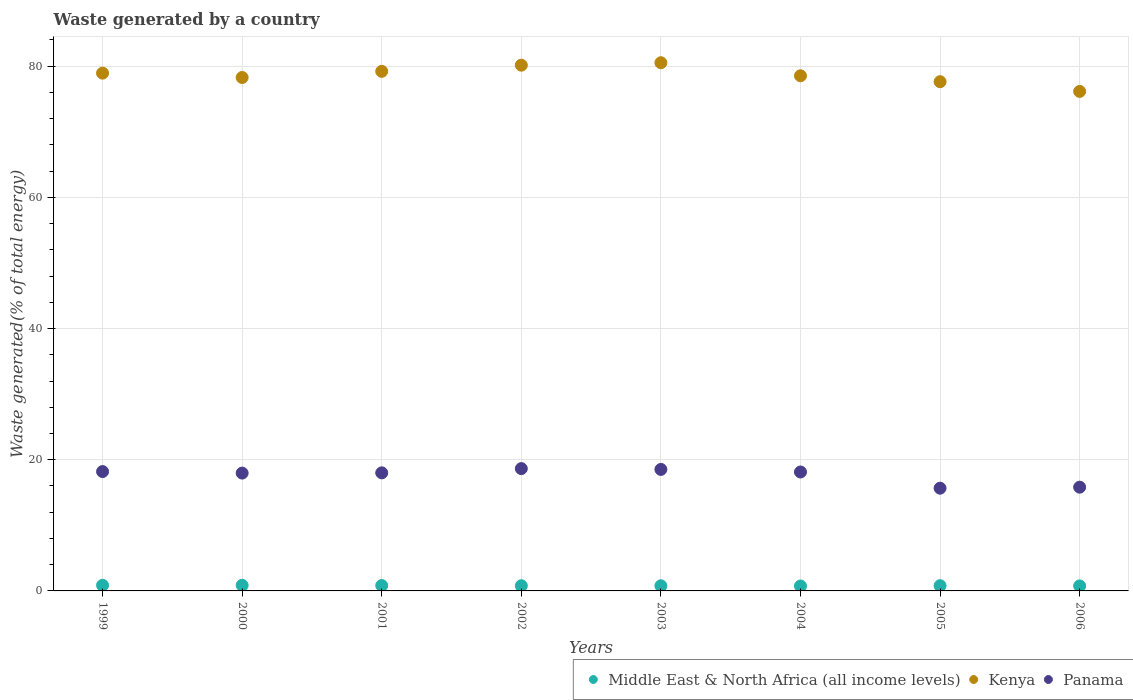How many different coloured dotlines are there?
Give a very brief answer. 3. Is the number of dotlines equal to the number of legend labels?
Offer a terse response. Yes. What is the total waste generated in Panama in 2006?
Keep it short and to the point. 15.82. Across all years, what is the maximum total waste generated in Middle East & North Africa (all income levels)?
Your response must be concise. 0.86. Across all years, what is the minimum total waste generated in Panama?
Your answer should be compact. 15.66. In which year was the total waste generated in Kenya maximum?
Give a very brief answer. 2003. What is the total total waste generated in Kenya in the graph?
Provide a succinct answer. 629.43. What is the difference between the total waste generated in Middle East & North Africa (all income levels) in 2003 and that in 2004?
Your answer should be very brief. 0.03. What is the difference between the total waste generated in Middle East & North Africa (all income levels) in 1999 and the total waste generated in Panama in 2005?
Give a very brief answer. -14.81. What is the average total waste generated in Middle East & North Africa (all income levels) per year?
Your answer should be compact. 0.8. In the year 2002, what is the difference between the total waste generated in Middle East & North Africa (all income levels) and total waste generated in Kenya?
Offer a very short reply. -79.36. What is the ratio of the total waste generated in Middle East & North Africa (all income levels) in 2002 to that in 2004?
Offer a very short reply. 1.05. What is the difference between the highest and the second highest total waste generated in Middle East & North Africa (all income levels)?
Ensure brevity in your answer.  0. What is the difference between the highest and the lowest total waste generated in Kenya?
Your answer should be compact. 4.37. In how many years, is the total waste generated in Panama greater than the average total waste generated in Panama taken over all years?
Ensure brevity in your answer.  6. Is the sum of the total waste generated in Middle East & North Africa (all income levels) in 2003 and 2004 greater than the maximum total waste generated in Panama across all years?
Make the answer very short. No. Is it the case that in every year, the sum of the total waste generated in Middle East & North Africa (all income levels) and total waste generated in Panama  is greater than the total waste generated in Kenya?
Your answer should be very brief. No. Does the total waste generated in Panama monotonically increase over the years?
Make the answer very short. No. Is the total waste generated in Panama strictly greater than the total waste generated in Kenya over the years?
Make the answer very short. No. Is the total waste generated in Middle East & North Africa (all income levels) strictly less than the total waste generated in Panama over the years?
Offer a very short reply. Yes. How many dotlines are there?
Keep it short and to the point. 3. How many years are there in the graph?
Offer a terse response. 8. What is the difference between two consecutive major ticks on the Y-axis?
Your answer should be very brief. 20. Are the values on the major ticks of Y-axis written in scientific E-notation?
Provide a short and direct response. No. Does the graph contain any zero values?
Offer a terse response. No. Where does the legend appear in the graph?
Your response must be concise. Bottom right. How are the legend labels stacked?
Ensure brevity in your answer.  Horizontal. What is the title of the graph?
Your response must be concise. Waste generated by a country. Does "West Bank and Gaza" appear as one of the legend labels in the graph?
Offer a very short reply. No. What is the label or title of the Y-axis?
Make the answer very short. Waste generated(% of total energy). What is the Waste generated(% of total energy) of Middle East & North Africa (all income levels) in 1999?
Your answer should be compact. 0.86. What is the Waste generated(% of total energy) in Kenya in 1999?
Provide a short and direct response. 78.94. What is the Waste generated(% of total energy) in Panama in 1999?
Your response must be concise. 18.2. What is the Waste generated(% of total energy) of Middle East & North Africa (all income levels) in 2000?
Give a very brief answer. 0.86. What is the Waste generated(% of total energy) of Kenya in 2000?
Make the answer very short. 78.28. What is the Waste generated(% of total energy) in Panama in 2000?
Offer a terse response. 17.96. What is the Waste generated(% of total energy) of Middle East & North Africa (all income levels) in 2001?
Give a very brief answer. 0.82. What is the Waste generated(% of total energy) of Kenya in 2001?
Offer a very short reply. 79.21. What is the Waste generated(% of total energy) of Panama in 2001?
Provide a short and direct response. 18. What is the Waste generated(% of total energy) in Middle East & North Africa (all income levels) in 2002?
Offer a terse response. 0.79. What is the Waste generated(% of total energy) in Kenya in 2002?
Ensure brevity in your answer.  80.15. What is the Waste generated(% of total energy) in Panama in 2002?
Provide a succinct answer. 18.65. What is the Waste generated(% of total energy) in Middle East & North Africa (all income levels) in 2003?
Offer a terse response. 0.78. What is the Waste generated(% of total energy) of Kenya in 2003?
Offer a very short reply. 80.52. What is the Waste generated(% of total energy) in Panama in 2003?
Ensure brevity in your answer.  18.52. What is the Waste generated(% of total energy) of Middle East & North Africa (all income levels) in 2004?
Your answer should be compact. 0.75. What is the Waste generated(% of total energy) of Kenya in 2004?
Your response must be concise. 78.54. What is the Waste generated(% of total energy) in Panama in 2004?
Give a very brief answer. 18.13. What is the Waste generated(% of total energy) in Middle East & North Africa (all income levels) in 2005?
Give a very brief answer. 0.8. What is the Waste generated(% of total energy) of Kenya in 2005?
Your answer should be compact. 77.63. What is the Waste generated(% of total energy) of Panama in 2005?
Keep it short and to the point. 15.66. What is the Waste generated(% of total energy) in Middle East & North Africa (all income levels) in 2006?
Offer a terse response. 0.77. What is the Waste generated(% of total energy) in Kenya in 2006?
Provide a succinct answer. 76.15. What is the Waste generated(% of total energy) of Panama in 2006?
Provide a short and direct response. 15.82. Across all years, what is the maximum Waste generated(% of total energy) of Middle East & North Africa (all income levels)?
Offer a very short reply. 0.86. Across all years, what is the maximum Waste generated(% of total energy) of Kenya?
Provide a short and direct response. 80.52. Across all years, what is the maximum Waste generated(% of total energy) of Panama?
Give a very brief answer. 18.65. Across all years, what is the minimum Waste generated(% of total energy) of Middle East & North Africa (all income levels)?
Keep it short and to the point. 0.75. Across all years, what is the minimum Waste generated(% of total energy) in Kenya?
Your answer should be very brief. 76.15. Across all years, what is the minimum Waste generated(% of total energy) in Panama?
Keep it short and to the point. 15.66. What is the total Waste generated(% of total energy) in Middle East & North Africa (all income levels) in the graph?
Offer a terse response. 6.42. What is the total Waste generated(% of total energy) of Kenya in the graph?
Provide a succinct answer. 629.42. What is the total Waste generated(% of total energy) of Panama in the graph?
Make the answer very short. 140.94. What is the difference between the Waste generated(% of total energy) in Middle East & North Africa (all income levels) in 1999 and that in 2000?
Keep it short and to the point. 0. What is the difference between the Waste generated(% of total energy) in Kenya in 1999 and that in 2000?
Make the answer very short. 0.66. What is the difference between the Waste generated(% of total energy) of Panama in 1999 and that in 2000?
Ensure brevity in your answer.  0.23. What is the difference between the Waste generated(% of total energy) in Middle East & North Africa (all income levels) in 1999 and that in 2001?
Provide a succinct answer. 0.04. What is the difference between the Waste generated(% of total energy) of Kenya in 1999 and that in 2001?
Offer a terse response. -0.27. What is the difference between the Waste generated(% of total energy) in Panama in 1999 and that in 2001?
Your response must be concise. 0.2. What is the difference between the Waste generated(% of total energy) of Middle East & North Africa (all income levels) in 1999 and that in 2002?
Your answer should be compact. 0.07. What is the difference between the Waste generated(% of total energy) in Kenya in 1999 and that in 2002?
Your response must be concise. -1.21. What is the difference between the Waste generated(% of total energy) of Panama in 1999 and that in 2002?
Provide a short and direct response. -0.45. What is the difference between the Waste generated(% of total energy) of Middle East & North Africa (all income levels) in 1999 and that in 2003?
Make the answer very short. 0.08. What is the difference between the Waste generated(% of total energy) of Kenya in 1999 and that in 2003?
Make the answer very short. -1.59. What is the difference between the Waste generated(% of total energy) of Panama in 1999 and that in 2003?
Provide a short and direct response. -0.32. What is the difference between the Waste generated(% of total energy) in Middle East & North Africa (all income levels) in 1999 and that in 2004?
Your response must be concise. 0.11. What is the difference between the Waste generated(% of total energy) in Kenya in 1999 and that in 2004?
Provide a succinct answer. 0.4. What is the difference between the Waste generated(% of total energy) in Panama in 1999 and that in 2004?
Offer a very short reply. 0.07. What is the difference between the Waste generated(% of total energy) of Middle East & North Africa (all income levels) in 1999 and that in 2005?
Ensure brevity in your answer.  0.06. What is the difference between the Waste generated(% of total energy) in Kenya in 1999 and that in 2005?
Offer a terse response. 1.3. What is the difference between the Waste generated(% of total energy) in Panama in 1999 and that in 2005?
Your answer should be very brief. 2.53. What is the difference between the Waste generated(% of total energy) of Middle East & North Africa (all income levels) in 1999 and that in 2006?
Your response must be concise. 0.09. What is the difference between the Waste generated(% of total energy) of Kenya in 1999 and that in 2006?
Your response must be concise. 2.79. What is the difference between the Waste generated(% of total energy) of Panama in 1999 and that in 2006?
Offer a terse response. 2.38. What is the difference between the Waste generated(% of total energy) in Middle East & North Africa (all income levels) in 2000 and that in 2001?
Your answer should be compact. 0.04. What is the difference between the Waste generated(% of total energy) of Kenya in 2000 and that in 2001?
Make the answer very short. -0.93. What is the difference between the Waste generated(% of total energy) in Panama in 2000 and that in 2001?
Your answer should be very brief. -0.04. What is the difference between the Waste generated(% of total energy) of Middle East & North Africa (all income levels) in 2000 and that in 2002?
Provide a succinct answer. 0.06. What is the difference between the Waste generated(% of total energy) of Kenya in 2000 and that in 2002?
Offer a very short reply. -1.88. What is the difference between the Waste generated(% of total energy) of Panama in 2000 and that in 2002?
Your answer should be very brief. -0.68. What is the difference between the Waste generated(% of total energy) of Middle East & North Africa (all income levels) in 2000 and that in 2003?
Keep it short and to the point. 0.07. What is the difference between the Waste generated(% of total energy) in Kenya in 2000 and that in 2003?
Give a very brief answer. -2.25. What is the difference between the Waste generated(% of total energy) of Panama in 2000 and that in 2003?
Provide a short and direct response. -0.56. What is the difference between the Waste generated(% of total energy) of Middle East & North Africa (all income levels) in 2000 and that in 2004?
Make the answer very short. 0.1. What is the difference between the Waste generated(% of total energy) in Kenya in 2000 and that in 2004?
Ensure brevity in your answer.  -0.26. What is the difference between the Waste generated(% of total energy) in Panama in 2000 and that in 2004?
Offer a terse response. -0.17. What is the difference between the Waste generated(% of total energy) of Middle East & North Africa (all income levels) in 2000 and that in 2005?
Keep it short and to the point. 0.06. What is the difference between the Waste generated(% of total energy) of Kenya in 2000 and that in 2005?
Offer a very short reply. 0.64. What is the difference between the Waste generated(% of total energy) of Panama in 2000 and that in 2005?
Offer a very short reply. 2.3. What is the difference between the Waste generated(% of total energy) in Middle East & North Africa (all income levels) in 2000 and that in 2006?
Offer a very short reply. 0.09. What is the difference between the Waste generated(% of total energy) of Kenya in 2000 and that in 2006?
Keep it short and to the point. 2.12. What is the difference between the Waste generated(% of total energy) of Panama in 2000 and that in 2006?
Offer a very short reply. 2.15. What is the difference between the Waste generated(% of total energy) of Middle East & North Africa (all income levels) in 2001 and that in 2002?
Keep it short and to the point. 0.03. What is the difference between the Waste generated(% of total energy) of Kenya in 2001 and that in 2002?
Make the answer very short. -0.94. What is the difference between the Waste generated(% of total energy) of Panama in 2001 and that in 2002?
Offer a terse response. -0.65. What is the difference between the Waste generated(% of total energy) of Middle East & North Africa (all income levels) in 2001 and that in 2003?
Offer a very short reply. 0.04. What is the difference between the Waste generated(% of total energy) in Kenya in 2001 and that in 2003?
Offer a terse response. -1.31. What is the difference between the Waste generated(% of total energy) in Panama in 2001 and that in 2003?
Your answer should be compact. -0.52. What is the difference between the Waste generated(% of total energy) in Middle East & North Africa (all income levels) in 2001 and that in 2004?
Give a very brief answer. 0.07. What is the difference between the Waste generated(% of total energy) in Kenya in 2001 and that in 2004?
Ensure brevity in your answer.  0.67. What is the difference between the Waste generated(% of total energy) in Panama in 2001 and that in 2004?
Your answer should be very brief. -0.13. What is the difference between the Waste generated(% of total energy) of Middle East & North Africa (all income levels) in 2001 and that in 2005?
Your response must be concise. 0.02. What is the difference between the Waste generated(% of total energy) of Kenya in 2001 and that in 2005?
Ensure brevity in your answer.  1.58. What is the difference between the Waste generated(% of total energy) in Panama in 2001 and that in 2005?
Your answer should be compact. 2.34. What is the difference between the Waste generated(% of total energy) of Middle East & North Africa (all income levels) in 2001 and that in 2006?
Give a very brief answer. 0.05. What is the difference between the Waste generated(% of total energy) of Kenya in 2001 and that in 2006?
Give a very brief answer. 3.06. What is the difference between the Waste generated(% of total energy) of Panama in 2001 and that in 2006?
Your response must be concise. 2.19. What is the difference between the Waste generated(% of total energy) of Middle East & North Africa (all income levels) in 2002 and that in 2003?
Keep it short and to the point. 0.01. What is the difference between the Waste generated(% of total energy) in Kenya in 2002 and that in 2003?
Your response must be concise. -0.37. What is the difference between the Waste generated(% of total energy) of Panama in 2002 and that in 2003?
Your answer should be compact. 0.13. What is the difference between the Waste generated(% of total energy) of Middle East & North Africa (all income levels) in 2002 and that in 2004?
Offer a terse response. 0.04. What is the difference between the Waste generated(% of total energy) of Kenya in 2002 and that in 2004?
Offer a very short reply. 1.62. What is the difference between the Waste generated(% of total energy) of Panama in 2002 and that in 2004?
Provide a short and direct response. 0.52. What is the difference between the Waste generated(% of total energy) of Middle East & North Africa (all income levels) in 2002 and that in 2005?
Make the answer very short. -0.01. What is the difference between the Waste generated(% of total energy) in Kenya in 2002 and that in 2005?
Your answer should be very brief. 2.52. What is the difference between the Waste generated(% of total energy) in Panama in 2002 and that in 2005?
Provide a succinct answer. 2.98. What is the difference between the Waste generated(% of total energy) of Middle East & North Africa (all income levels) in 2002 and that in 2006?
Your answer should be compact. 0.02. What is the difference between the Waste generated(% of total energy) in Kenya in 2002 and that in 2006?
Offer a terse response. 4. What is the difference between the Waste generated(% of total energy) in Panama in 2002 and that in 2006?
Give a very brief answer. 2.83. What is the difference between the Waste generated(% of total energy) of Middle East & North Africa (all income levels) in 2003 and that in 2004?
Offer a terse response. 0.03. What is the difference between the Waste generated(% of total energy) of Kenya in 2003 and that in 2004?
Your answer should be compact. 1.99. What is the difference between the Waste generated(% of total energy) in Panama in 2003 and that in 2004?
Ensure brevity in your answer.  0.39. What is the difference between the Waste generated(% of total energy) in Middle East & North Africa (all income levels) in 2003 and that in 2005?
Offer a terse response. -0.01. What is the difference between the Waste generated(% of total energy) of Kenya in 2003 and that in 2005?
Keep it short and to the point. 2.89. What is the difference between the Waste generated(% of total energy) in Panama in 2003 and that in 2005?
Ensure brevity in your answer.  2.86. What is the difference between the Waste generated(% of total energy) in Middle East & North Africa (all income levels) in 2003 and that in 2006?
Provide a short and direct response. 0.02. What is the difference between the Waste generated(% of total energy) of Kenya in 2003 and that in 2006?
Keep it short and to the point. 4.37. What is the difference between the Waste generated(% of total energy) in Panama in 2003 and that in 2006?
Ensure brevity in your answer.  2.71. What is the difference between the Waste generated(% of total energy) in Middle East & North Africa (all income levels) in 2004 and that in 2005?
Keep it short and to the point. -0.05. What is the difference between the Waste generated(% of total energy) of Kenya in 2004 and that in 2005?
Provide a succinct answer. 0.9. What is the difference between the Waste generated(% of total energy) in Panama in 2004 and that in 2005?
Give a very brief answer. 2.47. What is the difference between the Waste generated(% of total energy) in Middle East & North Africa (all income levels) in 2004 and that in 2006?
Your answer should be compact. -0.02. What is the difference between the Waste generated(% of total energy) in Kenya in 2004 and that in 2006?
Make the answer very short. 2.38. What is the difference between the Waste generated(% of total energy) of Panama in 2004 and that in 2006?
Offer a very short reply. 2.32. What is the difference between the Waste generated(% of total energy) in Middle East & North Africa (all income levels) in 2005 and that in 2006?
Offer a very short reply. 0.03. What is the difference between the Waste generated(% of total energy) of Kenya in 2005 and that in 2006?
Offer a terse response. 1.48. What is the difference between the Waste generated(% of total energy) in Panama in 2005 and that in 2006?
Keep it short and to the point. -0.15. What is the difference between the Waste generated(% of total energy) of Middle East & North Africa (all income levels) in 1999 and the Waste generated(% of total energy) of Kenya in 2000?
Your answer should be compact. -77.42. What is the difference between the Waste generated(% of total energy) of Middle East & North Africa (all income levels) in 1999 and the Waste generated(% of total energy) of Panama in 2000?
Keep it short and to the point. -17.11. What is the difference between the Waste generated(% of total energy) in Kenya in 1999 and the Waste generated(% of total energy) in Panama in 2000?
Give a very brief answer. 60.97. What is the difference between the Waste generated(% of total energy) in Middle East & North Africa (all income levels) in 1999 and the Waste generated(% of total energy) in Kenya in 2001?
Make the answer very short. -78.35. What is the difference between the Waste generated(% of total energy) in Middle East & North Africa (all income levels) in 1999 and the Waste generated(% of total energy) in Panama in 2001?
Ensure brevity in your answer.  -17.14. What is the difference between the Waste generated(% of total energy) in Kenya in 1999 and the Waste generated(% of total energy) in Panama in 2001?
Keep it short and to the point. 60.94. What is the difference between the Waste generated(% of total energy) in Middle East & North Africa (all income levels) in 1999 and the Waste generated(% of total energy) in Kenya in 2002?
Provide a short and direct response. -79.29. What is the difference between the Waste generated(% of total energy) of Middle East & North Africa (all income levels) in 1999 and the Waste generated(% of total energy) of Panama in 2002?
Your answer should be compact. -17.79. What is the difference between the Waste generated(% of total energy) of Kenya in 1999 and the Waste generated(% of total energy) of Panama in 2002?
Offer a terse response. 60.29. What is the difference between the Waste generated(% of total energy) of Middle East & North Africa (all income levels) in 1999 and the Waste generated(% of total energy) of Kenya in 2003?
Ensure brevity in your answer.  -79.67. What is the difference between the Waste generated(% of total energy) of Middle East & North Africa (all income levels) in 1999 and the Waste generated(% of total energy) of Panama in 2003?
Your response must be concise. -17.66. What is the difference between the Waste generated(% of total energy) of Kenya in 1999 and the Waste generated(% of total energy) of Panama in 2003?
Your answer should be compact. 60.42. What is the difference between the Waste generated(% of total energy) in Middle East & North Africa (all income levels) in 1999 and the Waste generated(% of total energy) in Kenya in 2004?
Keep it short and to the point. -77.68. What is the difference between the Waste generated(% of total energy) of Middle East & North Africa (all income levels) in 1999 and the Waste generated(% of total energy) of Panama in 2004?
Provide a short and direct response. -17.27. What is the difference between the Waste generated(% of total energy) of Kenya in 1999 and the Waste generated(% of total energy) of Panama in 2004?
Your answer should be compact. 60.81. What is the difference between the Waste generated(% of total energy) in Middle East & North Africa (all income levels) in 1999 and the Waste generated(% of total energy) in Kenya in 2005?
Your answer should be very brief. -76.78. What is the difference between the Waste generated(% of total energy) in Middle East & North Africa (all income levels) in 1999 and the Waste generated(% of total energy) in Panama in 2005?
Keep it short and to the point. -14.81. What is the difference between the Waste generated(% of total energy) in Kenya in 1999 and the Waste generated(% of total energy) in Panama in 2005?
Keep it short and to the point. 63.28. What is the difference between the Waste generated(% of total energy) of Middle East & North Africa (all income levels) in 1999 and the Waste generated(% of total energy) of Kenya in 2006?
Keep it short and to the point. -75.29. What is the difference between the Waste generated(% of total energy) in Middle East & North Africa (all income levels) in 1999 and the Waste generated(% of total energy) in Panama in 2006?
Give a very brief answer. -14.96. What is the difference between the Waste generated(% of total energy) in Kenya in 1999 and the Waste generated(% of total energy) in Panama in 2006?
Your answer should be compact. 63.12. What is the difference between the Waste generated(% of total energy) of Middle East & North Africa (all income levels) in 2000 and the Waste generated(% of total energy) of Kenya in 2001?
Provide a short and direct response. -78.35. What is the difference between the Waste generated(% of total energy) in Middle East & North Africa (all income levels) in 2000 and the Waste generated(% of total energy) in Panama in 2001?
Make the answer very short. -17.15. What is the difference between the Waste generated(% of total energy) of Kenya in 2000 and the Waste generated(% of total energy) of Panama in 2001?
Ensure brevity in your answer.  60.27. What is the difference between the Waste generated(% of total energy) in Middle East & North Africa (all income levels) in 2000 and the Waste generated(% of total energy) in Kenya in 2002?
Provide a succinct answer. -79.3. What is the difference between the Waste generated(% of total energy) of Middle East & North Africa (all income levels) in 2000 and the Waste generated(% of total energy) of Panama in 2002?
Ensure brevity in your answer.  -17.79. What is the difference between the Waste generated(% of total energy) in Kenya in 2000 and the Waste generated(% of total energy) in Panama in 2002?
Give a very brief answer. 59.63. What is the difference between the Waste generated(% of total energy) of Middle East & North Africa (all income levels) in 2000 and the Waste generated(% of total energy) of Kenya in 2003?
Offer a very short reply. -79.67. What is the difference between the Waste generated(% of total energy) in Middle East & North Africa (all income levels) in 2000 and the Waste generated(% of total energy) in Panama in 2003?
Provide a short and direct response. -17.67. What is the difference between the Waste generated(% of total energy) in Kenya in 2000 and the Waste generated(% of total energy) in Panama in 2003?
Offer a very short reply. 59.75. What is the difference between the Waste generated(% of total energy) in Middle East & North Africa (all income levels) in 2000 and the Waste generated(% of total energy) in Kenya in 2004?
Your response must be concise. -77.68. What is the difference between the Waste generated(% of total energy) of Middle East & North Africa (all income levels) in 2000 and the Waste generated(% of total energy) of Panama in 2004?
Your response must be concise. -17.28. What is the difference between the Waste generated(% of total energy) in Kenya in 2000 and the Waste generated(% of total energy) in Panama in 2004?
Offer a very short reply. 60.14. What is the difference between the Waste generated(% of total energy) in Middle East & North Africa (all income levels) in 2000 and the Waste generated(% of total energy) in Kenya in 2005?
Provide a succinct answer. -76.78. What is the difference between the Waste generated(% of total energy) of Middle East & North Africa (all income levels) in 2000 and the Waste generated(% of total energy) of Panama in 2005?
Ensure brevity in your answer.  -14.81. What is the difference between the Waste generated(% of total energy) in Kenya in 2000 and the Waste generated(% of total energy) in Panama in 2005?
Provide a short and direct response. 62.61. What is the difference between the Waste generated(% of total energy) in Middle East & North Africa (all income levels) in 2000 and the Waste generated(% of total energy) in Kenya in 2006?
Your answer should be very brief. -75.3. What is the difference between the Waste generated(% of total energy) in Middle East & North Africa (all income levels) in 2000 and the Waste generated(% of total energy) in Panama in 2006?
Your answer should be compact. -14.96. What is the difference between the Waste generated(% of total energy) in Kenya in 2000 and the Waste generated(% of total energy) in Panama in 2006?
Offer a terse response. 62.46. What is the difference between the Waste generated(% of total energy) in Middle East & North Africa (all income levels) in 2001 and the Waste generated(% of total energy) in Kenya in 2002?
Give a very brief answer. -79.33. What is the difference between the Waste generated(% of total energy) of Middle East & North Africa (all income levels) in 2001 and the Waste generated(% of total energy) of Panama in 2002?
Provide a short and direct response. -17.83. What is the difference between the Waste generated(% of total energy) in Kenya in 2001 and the Waste generated(% of total energy) in Panama in 2002?
Your answer should be compact. 60.56. What is the difference between the Waste generated(% of total energy) in Middle East & North Africa (all income levels) in 2001 and the Waste generated(% of total energy) in Kenya in 2003?
Ensure brevity in your answer.  -79.7. What is the difference between the Waste generated(% of total energy) in Middle East & North Africa (all income levels) in 2001 and the Waste generated(% of total energy) in Panama in 2003?
Keep it short and to the point. -17.7. What is the difference between the Waste generated(% of total energy) in Kenya in 2001 and the Waste generated(% of total energy) in Panama in 2003?
Offer a very short reply. 60.69. What is the difference between the Waste generated(% of total energy) of Middle East & North Africa (all income levels) in 2001 and the Waste generated(% of total energy) of Kenya in 2004?
Make the answer very short. -77.72. What is the difference between the Waste generated(% of total energy) of Middle East & North Africa (all income levels) in 2001 and the Waste generated(% of total energy) of Panama in 2004?
Your answer should be very brief. -17.31. What is the difference between the Waste generated(% of total energy) in Kenya in 2001 and the Waste generated(% of total energy) in Panama in 2004?
Ensure brevity in your answer.  61.08. What is the difference between the Waste generated(% of total energy) in Middle East & North Africa (all income levels) in 2001 and the Waste generated(% of total energy) in Kenya in 2005?
Ensure brevity in your answer.  -76.81. What is the difference between the Waste generated(% of total energy) of Middle East & North Africa (all income levels) in 2001 and the Waste generated(% of total energy) of Panama in 2005?
Provide a succinct answer. -14.84. What is the difference between the Waste generated(% of total energy) in Kenya in 2001 and the Waste generated(% of total energy) in Panama in 2005?
Your answer should be very brief. 63.55. What is the difference between the Waste generated(% of total energy) in Middle East & North Africa (all income levels) in 2001 and the Waste generated(% of total energy) in Kenya in 2006?
Provide a short and direct response. -75.33. What is the difference between the Waste generated(% of total energy) in Middle East & North Africa (all income levels) in 2001 and the Waste generated(% of total energy) in Panama in 2006?
Offer a terse response. -15. What is the difference between the Waste generated(% of total energy) in Kenya in 2001 and the Waste generated(% of total energy) in Panama in 2006?
Give a very brief answer. 63.39. What is the difference between the Waste generated(% of total energy) of Middle East & North Africa (all income levels) in 2002 and the Waste generated(% of total energy) of Kenya in 2003?
Offer a terse response. -79.73. What is the difference between the Waste generated(% of total energy) in Middle East & North Africa (all income levels) in 2002 and the Waste generated(% of total energy) in Panama in 2003?
Provide a short and direct response. -17.73. What is the difference between the Waste generated(% of total energy) of Kenya in 2002 and the Waste generated(% of total energy) of Panama in 2003?
Offer a terse response. 61.63. What is the difference between the Waste generated(% of total energy) of Middle East & North Africa (all income levels) in 2002 and the Waste generated(% of total energy) of Kenya in 2004?
Give a very brief answer. -77.75. What is the difference between the Waste generated(% of total energy) of Middle East & North Africa (all income levels) in 2002 and the Waste generated(% of total energy) of Panama in 2004?
Give a very brief answer. -17.34. What is the difference between the Waste generated(% of total energy) in Kenya in 2002 and the Waste generated(% of total energy) in Panama in 2004?
Your answer should be compact. 62.02. What is the difference between the Waste generated(% of total energy) of Middle East & North Africa (all income levels) in 2002 and the Waste generated(% of total energy) of Kenya in 2005?
Provide a succinct answer. -76.84. What is the difference between the Waste generated(% of total energy) in Middle East & North Africa (all income levels) in 2002 and the Waste generated(% of total energy) in Panama in 2005?
Provide a succinct answer. -14.87. What is the difference between the Waste generated(% of total energy) of Kenya in 2002 and the Waste generated(% of total energy) of Panama in 2005?
Your answer should be very brief. 64.49. What is the difference between the Waste generated(% of total energy) in Middle East & North Africa (all income levels) in 2002 and the Waste generated(% of total energy) in Kenya in 2006?
Ensure brevity in your answer.  -75.36. What is the difference between the Waste generated(% of total energy) in Middle East & North Africa (all income levels) in 2002 and the Waste generated(% of total energy) in Panama in 2006?
Offer a very short reply. -15.02. What is the difference between the Waste generated(% of total energy) of Kenya in 2002 and the Waste generated(% of total energy) of Panama in 2006?
Your answer should be very brief. 64.34. What is the difference between the Waste generated(% of total energy) of Middle East & North Africa (all income levels) in 2003 and the Waste generated(% of total energy) of Kenya in 2004?
Offer a terse response. -77.75. What is the difference between the Waste generated(% of total energy) in Middle East & North Africa (all income levels) in 2003 and the Waste generated(% of total energy) in Panama in 2004?
Your answer should be compact. -17.35. What is the difference between the Waste generated(% of total energy) in Kenya in 2003 and the Waste generated(% of total energy) in Panama in 2004?
Offer a terse response. 62.39. What is the difference between the Waste generated(% of total energy) in Middle East & North Africa (all income levels) in 2003 and the Waste generated(% of total energy) in Kenya in 2005?
Your answer should be compact. -76.85. What is the difference between the Waste generated(% of total energy) of Middle East & North Africa (all income levels) in 2003 and the Waste generated(% of total energy) of Panama in 2005?
Your answer should be very brief. -14.88. What is the difference between the Waste generated(% of total energy) of Kenya in 2003 and the Waste generated(% of total energy) of Panama in 2005?
Your answer should be very brief. 64.86. What is the difference between the Waste generated(% of total energy) of Middle East & North Africa (all income levels) in 2003 and the Waste generated(% of total energy) of Kenya in 2006?
Offer a terse response. -75.37. What is the difference between the Waste generated(% of total energy) of Middle East & North Africa (all income levels) in 2003 and the Waste generated(% of total energy) of Panama in 2006?
Your answer should be very brief. -15.03. What is the difference between the Waste generated(% of total energy) in Kenya in 2003 and the Waste generated(% of total energy) in Panama in 2006?
Provide a short and direct response. 64.71. What is the difference between the Waste generated(% of total energy) of Middle East & North Africa (all income levels) in 2004 and the Waste generated(% of total energy) of Kenya in 2005?
Provide a short and direct response. -76.88. What is the difference between the Waste generated(% of total energy) of Middle East & North Africa (all income levels) in 2004 and the Waste generated(% of total energy) of Panama in 2005?
Keep it short and to the point. -14.91. What is the difference between the Waste generated(% of total energy) of Kenya in 2004 and the Waste generated(% of total energy) of Panama in 2005?
Provide a short and direct response. 62.87. What is the difference between the Waste generated(% of total energy) in Middle East & North Africa (all income levels) in 2004 and the Waste generated(% of total energy) in Kenya in 2006?
Offer a terse response. -75.4. What is the difference between the Waste generated(% of total energy) of Middle East & North Africa (all income levels) in 2004 and the Waste generated(% of total energy) of Panama in 2006?
Provide a short and direct response. -15.06. What is the difference between the Waste generated(% of total energy) in Kenya in 2004 and the Waste generated(% of total energy) in Panama in 2006?
Provide a succinct answer. 62.72. What is the difference between the Waste generated(% of total energy) in Middle East & North Africa (all income levels) in 2005 and the Waste generated(% of total energy) in Kenya in 2006?
Offer a very short reply. -75.36. What is the difference between the Waste generated(% of total energy) of Middle East & North Africa (all income levels) in 2005 and the Waste generated(% of total energy) of Panama in 2006?
Offer a terse response. -15.02. What is the difference between the Waste generated(% of total energy) in Kenya in 2005 and the Waste generated(% of total energy) in Panama in 2006?
Keep it short and to the point. 61.82. What is the average Waste generated(% of total energy) of Middle East & North Africa (all income levels) per year?
Give a very brief answer. 0.8. What is the average Waste generated(% of total energy) of Kenya per year?
Your response must be concise. 78.68. What is the average Waste generated(% of total energy) of Panama per year?
Your response must be concise. 17.62. In the year 1999, what is the difference between the Waste generated(% of total energy) in Middle East & North Africa (all income levels) and Waste generated(% of total energy) in Kenya?
Give a very brief answer. -78.08. In the year 1999, what is the difference between the Waste generated(% of total energy) of Middle East & North Africa (all income levels) and Waste generated(% of total energy) of Panama?
Ensure brevity in your answer.  -17.34. In the year 1999, what is the difference between the Waste generated(% of total energy) in Kenya and Waste generated(% of total energy) in Panama?
Your response must be concise. 60.74. In the year 2000, what is the difference between the Waste generated(% of total energy) in Middle East & North Africa (all income levels) and Waste generated(% of total energy) in Kenya?
Your answer should be very brief. -77.42. In the year 2000, what is the difference between the Waste generated(% of total energy) in Middle East & North Africa (all income levels) and Waste generated(% of total energy) in Panama?
Provide a succinct answer. -17.11. In the year 2000, what is the difference between the Waste generated(% of total energy) in Kenya and Waste generated(% of total energy) in Panama?
Provide a short and direct response. 60.31. In the year 2001, what is the difference between the Waste generated(% of total energy) in Middle East & North Africa (all income levels) and Waste generated(% of total energy) in Kenya?
Your response must be concise. -78.39. In the year 2001, what is the difference between the Waste generated(% of total energy) of Middle East & North Africa (all income levels) and Waste generated(% of total energy) of Panama?
Provide a succinct answer. -17.18. In the year 2001, what is the difference between the Waste generated(% of total energy) of Kenya and Waste generated(% of total energy) of Panama?
Keep it short and to the point. 61.21. In the year 2002, what is the difference between the Waste generated(% of total energy) of Middle East & North Africa (all income levels) and Waste generated(% of total energy) of Kenya?
Your answer should be compact. -79.36. In the year 2002, what is the difference between the Waste generated(% of total energy) of Middle East & North Africa (all income levels) and Waste generated(% of total energy) of Panama?
Your answer should be very brief. -17.86. In the year 2002, what is the difference between the Waste generated(% of total energy) of Kenya and Waste generated(% of total energy) of Panama?
Give a very brief answer. 61.5. In the year 2003, what is the difference between the Waste generated(% of total energy) in Middle East & North Africa (all income levels) and Waste generated(% of total energy) in Kenya?
Ensure brevity in your answer.  -79.74. In the year 2003, what is the difference between the Waste generated(% of total energy) of Middle East & North Africa (all income levels) and Waste generated(% of total energy) of Panama?
Offer a terse response. -17.74. In the year 2003, what is the difference between the Waste generated(% of total energy) in Kenya and Waste generated(% of total energy) in Panama?
Offer a terse response. 62. In the year 2004, what is the difference between the Waste generated(% of total energy) of Middle East & North Africa (all income levels) and Waste generated(% of total energy) of Kenya?
Your answer should be compact. -77.79. In the year 2004, what is the difference between the Waste generated(% of total energy) in Middle East & North Africa (all income levels) and Waste generated(% of total energy) in Panama?
Keep it short and to the point. -17.38. In the year 2004, what is the difference between the Waste generated(% of total energy) of Kenya and Waste generated(% of total energy) of Panama?
Make the answer very short. 60.4. In the year 2005, what is the difference between the Waste generated(% of total energy) in Middle East & North Africa (all income levels) and Waste generated(% of total energy) in Kenya?
Give a very brief answer. -76.84. In the year 2005, what is the difference between the Waste generated(% of total energy) of Middle East & North Africa (all income levels) and Waste generated(% of total energy) of Panama?
Offer a very short reply. -14.87. In the year 2005, what is the difference between the Waste generated(% of total energy) in Kenya and Waste generated(% of total energy) in Panama?
Keep it short and to the point. 61.97. In the year 2006, what is the difference between the Waste generated(% of total energy) in Middle East & North Africa (all income levels) and Waste generated(% of total energy) in Kenya?
Ensure brevity in your answer.  -75.39. In the year 2006, what is the difference between the Waste generated(% of total energy) in Middle East & North Africa (all income levels) and Waste generated(% of total energy) in Panama?
Give a very brief answer. -15.05. In the year 2006, what is the difference between the Waste generated(% of total energy) in Kenya and Waste generated(% of total energy) in Panama?
Provide a short and direct response. 60.34. What is the ratio of the Waste generated(% of total energy) in Middle East & North Africa (all income levels) in 1999 to that in 2000?
Make the answer very short. 1. What is the ratio of the Waste generated(% of total energy) of Kenya in 1999 to that in 2000?
Your response must be concise. 1.01. What is the ratio of the Waste generated(% of total energy) of Middle East & North Africa (all income levels) in 1999 to that in 2001?
Provide a short and direct response. 1.05. What is the ratio of the Waste generated(% of total energy) of Panama in 1999 to that in 2001?
Offer a terse response. 1.01. What is the ratio of the Waste generated(% of total energy) of Middle East & North Africa (all income levels) in 1999 to that in 2002?
Give a very brief answer. 1.08. What is the ratio of the Waste generated(% of total energy) of Kenya in 1999 to that in 2002?
Your answer should be very brief. 0.98. What is the ratio of the Waste generated(% of total energy) in Panama in 1999 to that in 2002?
Give a very brief answer. 0.98. What is the ratio of the Waste generated(% of total energy) in Middle East & North Africa (all income levels) in 1999 to that in 2003?
Keep it short and to the point. 1.1. What is the ratio of the Waste generated(% of total energy) in Kenya in 1999 to that in 2003?
Keep it short and to the point. 0.98. What is the ratio of the Waste generated(% of total energy) in Panama in 1999 to that in 2003?
Keep it short and to the point. 0.98. What is the ratio of the Waste generated(% of total energy) in Middle East & North Africa (all income levels) in 1999 to that in 2004?
Provide a short and direct response. 1.14. What is the ratio of the Waste generated(% of total energy) in Kenya in 1999 to that in 2004?
Your answer should be compact. 1.01. What is the ratio of the Waste generated(% of total energy) of Panama in 1999 to that in 2004?
Your response must be concise. 1. What is the ratio of the Waste generated(% of total energy) in Middle East & North Africa (all income levels) in 1999 to that in 2005?
Your response must be concise. 1.08. What is the ratio of the Waste generated(% of total energy) of Kenya in 1999 to that in 2005?
Provide a short and direct response. 1.02. What is the ratio of the Waste generated(% of total energy) of Panama in 1999 to that in 2005?
Keep it short and to the point. 1.16. What is the ratio of the Waste generated(% of total energy) of Middle East & North Africa (all income levels) in 1999 to that in 2006?
Provide a short and direct response. 1.12. What is the ratio of the Waste generated(% of total energy) in Kenya in 1999 to that in 2006?
Make the answer very short. 1.04. What is the ratio of the Waste generated(% of total energy) in Panama in 1999 to that in 2006?
Provide a short and direct response. 1.15. What is the ratio of the Waste generated(% of total energy) of Middle East & North Africa (all income levels) in 2000 to that in 2001?
Give a very brief answer. 1.04. What is the ratio of the Waste generated(% of total energy) in Kenya in 2000 to that in 2001?
Keep it short and to the point. 0.99. What is the ratio of the Waste generated(% of total energy) in Panama in 2000 to that in 2001?
Your answer should be compact. 1. What is the ratio of the Waste generated(% of total energy) in Middle East & North Africa (all income levels) in 2000 to that in 2002?
Provide a succinct answer. 1.08. What is the ratio of the Waste generated(% of total energy) of Kenya in 2000 to that in 2002?
Make the answer very short. 0.98. What is the ratio of the Waste generated(% of total energy) of Panama in 2000 to that in 2002?
Your response must be concise. 0.96. What is the ratio of the Waste generated(% of total energy) of Middle East & North Africa (all income levels) in 2000 to that in 2003?
Your answer should be compact. 1.09. What is the ratio of the Waste generated(% of total energy) of Kenya in 2000 to that in 2003?
Your response must be concise. 0.97. What is the ratio of the Waste generated(% of total energy) of Panama in 2000 to that in 2003?
Your answer should be compact. 0.97. What is the ratio of the Waste generated(% of total energy) in Middle East & North Africa (all income levels) in 2000 to that in 2004?
Your answer should be compact. 1.14. What is the ratio of the Waste generated(% of total energy) of Kenya in 2000 to that in 2004?
Provide a succinct answer. 1. What is the ratio of the Waste generated(% of total energy) in Panama in 2000 to that in 2004?
Provide a succinct answer. 0.99. What is the ratio of the Waste generated(% of total energy) in Middle East & North Africa (all income levels) in 2000 to that in 2005?
Give a very brief answer. 1.07. What is the ratio of the Waste generated(% of total energy) of Kenya in 2000 to that in 2005?
Keep it short and to the point. 1.01. What is the ratio of the Waste generated(% of total energy) of Panama in 2000 to that in 2005?
Provide a succinct answer. 1.15. What is the ratio of the Waste generated(% of total energy) of Middle East & North Africa (all income levels) in 2000 to that in 2006?
Your response must be concise. 1.12. What is the ratio of the Waste generated(% of total energy) of Kenya in 2000 to that in 2006?
Ensure brevity in your answer.  1.03. What is the ratio of the Waste generated(% of total energy) of Panama in 2000 to that in 2006?
Ensure brevity in your answer.  1.14. What is the ratio of the Waste generated(% of total energy) in Middle East & North Africa (all income levels) in 2001 to that in 2002?
Give a very brief answer. 1.04. What is the ratio of the Waste generated(% of total energy) in Panama in 2001 to that in 2002?
Ensure brevity in your answer.  0.97. What is the ratio of the Waste generated(% of total energy) in Middle East & North Africa (all income levels) in 2001 to that in 2003?
Your answer should be compact. 1.05. What is the ratio of the Waste generated(% of total energy) in Kenya in 2001 to that in 2003?
Ensure brevity in your answer.  0.98. What is the ratio of the Waste generated(% of total energy) of Panama in 2001 to that in 2003?
Make the answer very short. 0.97. What is the ratio of the Waste generated(% of total energy) in Middle East & North Africa (all income levels) in 2001 to that in 2004?
Offer a terse response. 1.09. What is the ratio of the Waste generated(% of total energy) of Kenya in 2001 to that in 2004?
Keep it short and to the point. 1.01. What is the ratio of the Waste generated(% of total energy) of Panama in 2001 to that in 2004?
Make the answer very short. 0.99. What is the ratio of the Waste generated(% of total energy) of Middle East & North Africa (all income levels) in 2001 to that in 2005?
Provide a short and direct response. 1.03. What is the ratio of the Waste generated(% of total energy) of Kenya in 2001 to that in 2005?
Offer a terse response. 1.02. What is the ratio of the Waste generated(% of total energy) in Panama in 2001 to that in 2005?
Ensure brevity in your answer.  1.15. What is the ratio of the Waste generated(% of total energy) in Middle East & North Africa (all income levels) in 2001 to that in 2006?
Give a very brief answer. 1.07. What is the ratio of the Waste generated(% of total energy) of Kenya in 2001 to that in 2006?
Keep it short and to the point. 1.04. What is the ratio of the Waste generated(% of total energy) in Panama in 2001 to that in 2006?
Provide a short and direct response. 1.14. What is the ratio of the Waste generated(% of total energy) of Panama in 2002 to that in 2003?
Keep it short and to the point. 1.01. What is the ratio of the Waste generated(% of total energy) of Middle East & North Africa (all income levels) in 2002 to that in 2004?
Your answer should be very brief. 1.05. What is the ratio of the Waste generated(% of total energy) of Kenya in 2002 to that in 2004?
Your response must be concise. 1.02. What is the ratio of the Waste generated(% of total energy) in Panama in 2002 to that in 2004?
Offer a very short reply. 1.03. What is the ratio of the Waste generated(% of total energy) in Kenya in 2002 to that in 2005?
Your answer should be compact. 1.03. What is the ratio of the Waste generated(% of total energy) of Panama in 2002 to that in 2005?
Your answer should be very brief. 1.19. What is the ratio of the Waste generated(% of total energy) in Middle East & North Africa (all income levels) in 2002 to that in 2006?
Ensure brevity in your answer.  1.03. What is the ratio of the Waste generated(% of total energy) of Kenya in 2002 to that in 2006?
Make the answer very short. 1.05. What is the ratio of the Waste generated(% of total energy) in Panama in 2002 to that in 2006?
Provide a succinct answer. 1.18. What is the ratio of the Waste generated(% of total energy) in Middle East & North Africa (all income levels) in 2003 to that in 2004?
Your answer should be compact. 1.04. What is the ratio of the Waste generated(% of total energy) in Kenya in 2003 to that in 2004?
Provide a succinct answer. 1.03. What is the ratio of the Waste generated(% of total energy) of Panama in 2003 to that in 2004?
Your answer should be compact. 1.02. What is the ratio of the Waste generated(% of total energy) in Middle East & North Africa (all income levels) in 2003 to that in 2005?
Provide a short and direct response. 0.98. What is the ratio of the Waste generated(% of total energy) in Kenya in 2003 to that in 2005?
Make the answer very short. 1.04. What is the ratio of the Waste generated(% of total energy) of Panama in 2003 to that in 2005?
Provide a succinct answer. 1.18. What is the ratio of the Waste generated(% of total energy) in Middle East & North Africa (all income levels) in 2003 to that in 2006?
Offer a terse response. 1.02. What is the ratio of the Waste generated(% of total energy) in Kenya in 2003 to that in 2006?
Ensure brevity in your answer.  1.06. What is the ratio of the Waste generated(% of total energy) of Panama in 2003 to that in 2006?
Give a very brief answer. 1.17. What is the ratio of the Waste generated(% of total energy) in Middle East & North Africa (all income levels) in 2004 to that in 2005?
Provide a short and direct response. 0.94. What is the ratio of the Waste generated(% of total energy) of Kenya in 2004 to that in 2005?
Your answer should be very brief. 1.01. What is the ratio of the Waste generated(% of total energy) of Panama in 2004 to that in 2005?
Offer a terse response. 1.16. What is the ratio of the Waste generated(% of total energy) in Middle East & North Africa (all income levels) in 2004 to that in 2006?
Give a very brief answer. 0.98. What is the ratio of the Waste generated(% of total energy) in Kenya in 2004 to that in 2006?
Make the answer very short. 1.03. What is the ratio of the Waste generated(% of total energy) of Panama in 2004 to that in 2006?
Offer a terse response. 1.15. What is the ratio of the Waste generated(% of total energy) of Middle East & North Africa (all income levels) in 2005 to that in 2006?
Give a very brief answer. 1.04. What is the ratio of the Waste generated(% of total energy) in Kenya in 2005 to that in 2006?
Offer a terse response. 1.02. What is the ratio of the Waste generated(% of total energy) in Panama in 2005 to that in 2006?
Provide a short and direct response. 0.99. What is the difference between the highest and the second highest Waste generated(% of total energy) of Middle East & North Africa (all income levels)?
Offer a terse response. 0. What is the difference between the highest and the second highest Waste generated(% of total energy) of Kenya?
Provide a short and direct response. 0.37. What is the difference between the highest and the second highest Waste generated(% of total energy) of Panama?
Keep it short and to the point. 0.13. What is the difference between the highest and the lowest Waste generated(% of total energy) in Middle East & North Africa (all income levels)?
Make the answer very short. 0.11. What is the difference between the highest and the lowest Waste generated(% of total energy) of Kenya?
Your answer should be compact. 4.37. What is the difference between the highest and the lowest Waste generated(% of total energy) of Panama?
Provide a succinct answer. 2.98. 